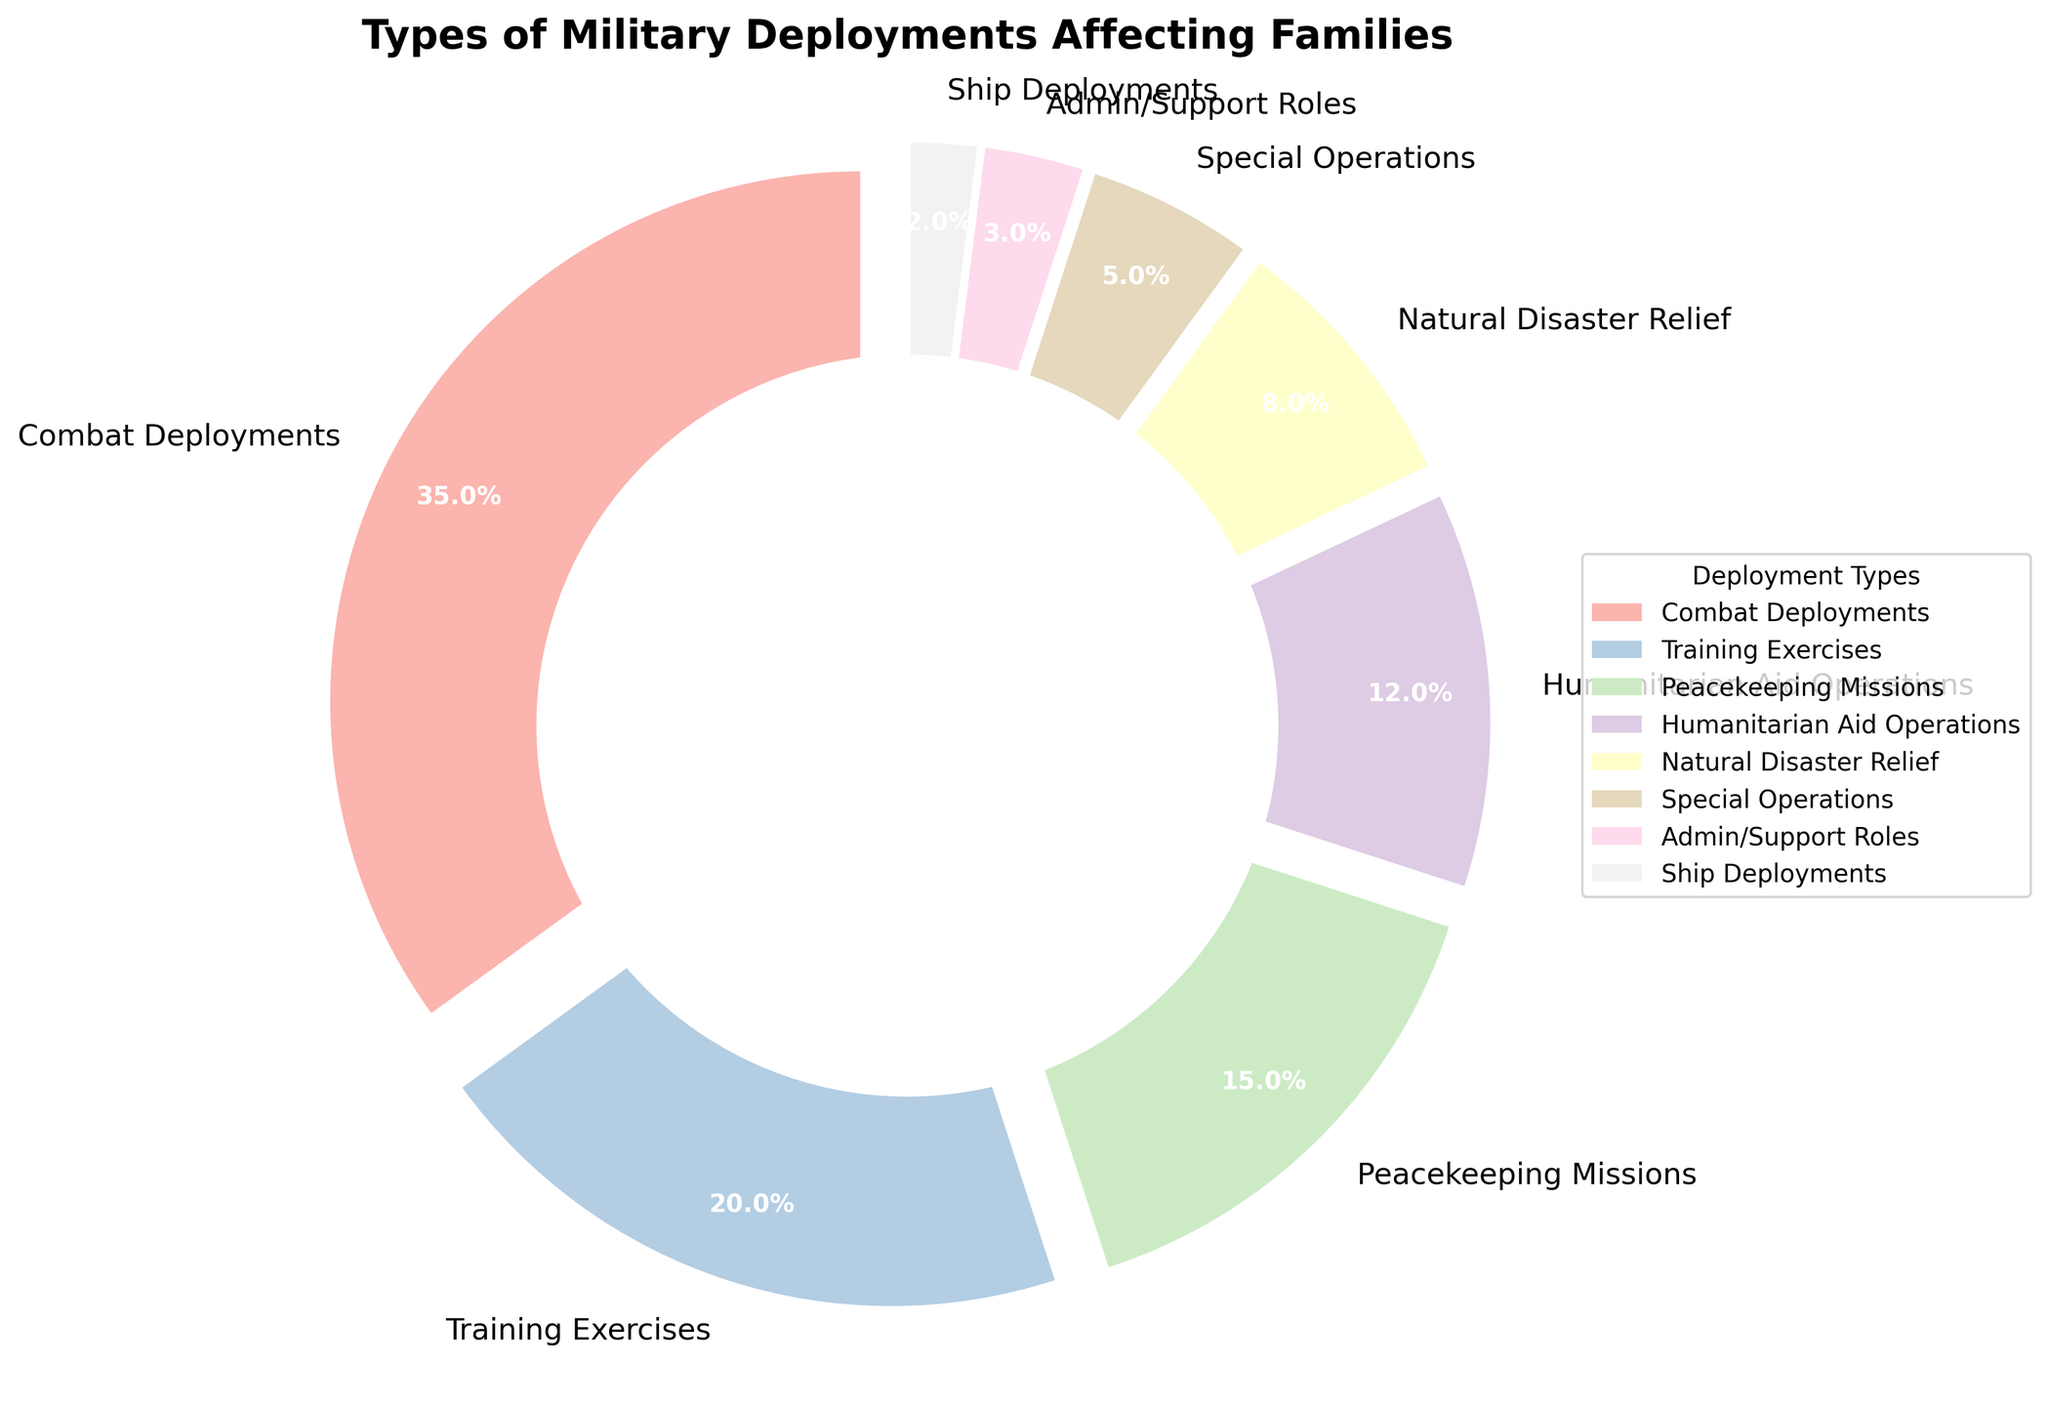Which type of deployment has the highest prevalence percentage? The pie chart shows different types of military deployments with their respective percentages. By examining the wedges, you can see that Combat Deployments hold the largest portion, which is labeled at 35%.
Answer: Combat Deployments Which type of deployment is least prevalent? The pie chart indicates the prevalence percentages of various deployments. The smallest wedge corresponds to Ship Deployments, which is labeled at 2%.
Answer: Ship Deployments What is the combined percentage of Training Exercises, Peacekeeping Missions, and Humanitarian Aid Operations? Add the percentages for Training Exercises (20%), Peacekeeping Missions (15%), and Humanitarian Aid Operations (12%). So, 20 + 15 + 12 = 47%.
Answer: 47% Which has a greater percentage: Natural Disaster Relief or Special Operations? By comparing the wedges, it's clear that Natural Disaster Relief (8%) is greater than Special Operations (5%).
Answer: Natural Disaster Relief What is the combined percentage of deployments other than Combat Deployments? Sum the percentages of all the deployments except for Combat Deployments: Training Exercises (20%), Peacekeeping Missions (15%), Humanitarian Aid Operations (12%), Natural Disaster Relief (8%), Special Operations (5%), Admin/Support Roles (3%), and Ship Deployments (2%). 20 + 15 + 12 + 8 + 5 + 3 + 2 = 65%.
Answer: 65% How do the percentages of Admin/Support Roles and Ship Deployments compare to each other? The chart shows that Admin/Support Roles have a percentage of 3%, while Ship Deployments are at 2%. Therefore, Admin/Support Roles have a higher percentage compared to Ship Deployments.
Answer: Admin/Support Roles Is the percentage of Peacekeeping Missions greater than that of Humanitarian Aid Operations? By looking at the wedges, Peacekeeping Missions have a percentage of 15%, which is indeed greater than Humanitarian Aid Operations at 12%.
Answer: Yes What is the total percentage for deployments categorized under Combat Deployments, Special Operations, and Admin/Support Roles? Add the percentages of Combat Deployments (35%), Special Operations (5%), and Admin/Support Roles (3%). 35 + 5 + 3 = 43%.
Answer: 43% What visual attribute makes Training Exercises stand out on the pie chart? The wedge for Training Exercises looks slightly larger compared to others and it's highlighted with an explosion effect, which makes it stand out visually.
Answer: Explosion effect Comparatively, how does the size of the wedge for Humanitarian Aid Operations relate to that of Natural Disaster Relief? The wedge for Humanitarian Aid Operations (12%) is larger than the wedge for Natural Disaster Relief (8%), both visually and percentage-wise.
Answer: Larger 